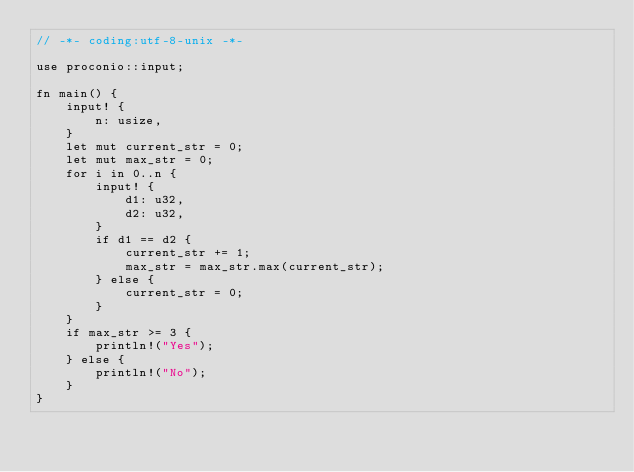<code> <loc_0><loc_0><loc_500><loc_500><_Rust_>// -*- coding:utf-8-unix -*-

use proconio::input;

fn main() {
    input! {
        n: usize,
    }
    let mut current_str = 0;
    let mut max_str = 0;
    for i in 0..n {
        input! {
            d1: u32,
            d2: u32,
        }
        if d1 == d2 {
            current_str += 1;
            max_str = max_str.max(current_str);
        } else {
            current_str = 0;
        }
    }
    if max_str >= 3 {
        println!("Yes");
    } else {
        println!("No");
    }
}
</code> 